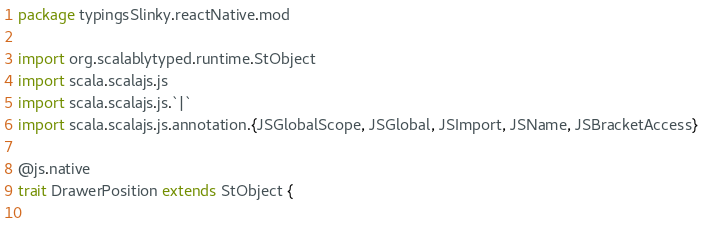<code> <loc_0><loc_0><loc_500><loc_500><_Scala_>package typingsSlinky.reactNative.mod

import org.scalablytyped.runtime.StObject
import scala.scalajs.js
import scala.scalajs.js.`|`
import scala.scalajs.js.annotation.{JSGlobalScope, JSGlobal, JSImport, JSName, JSBracketAccess}

@js.native
trait DrawerPosition extends StObject {
  </code> 